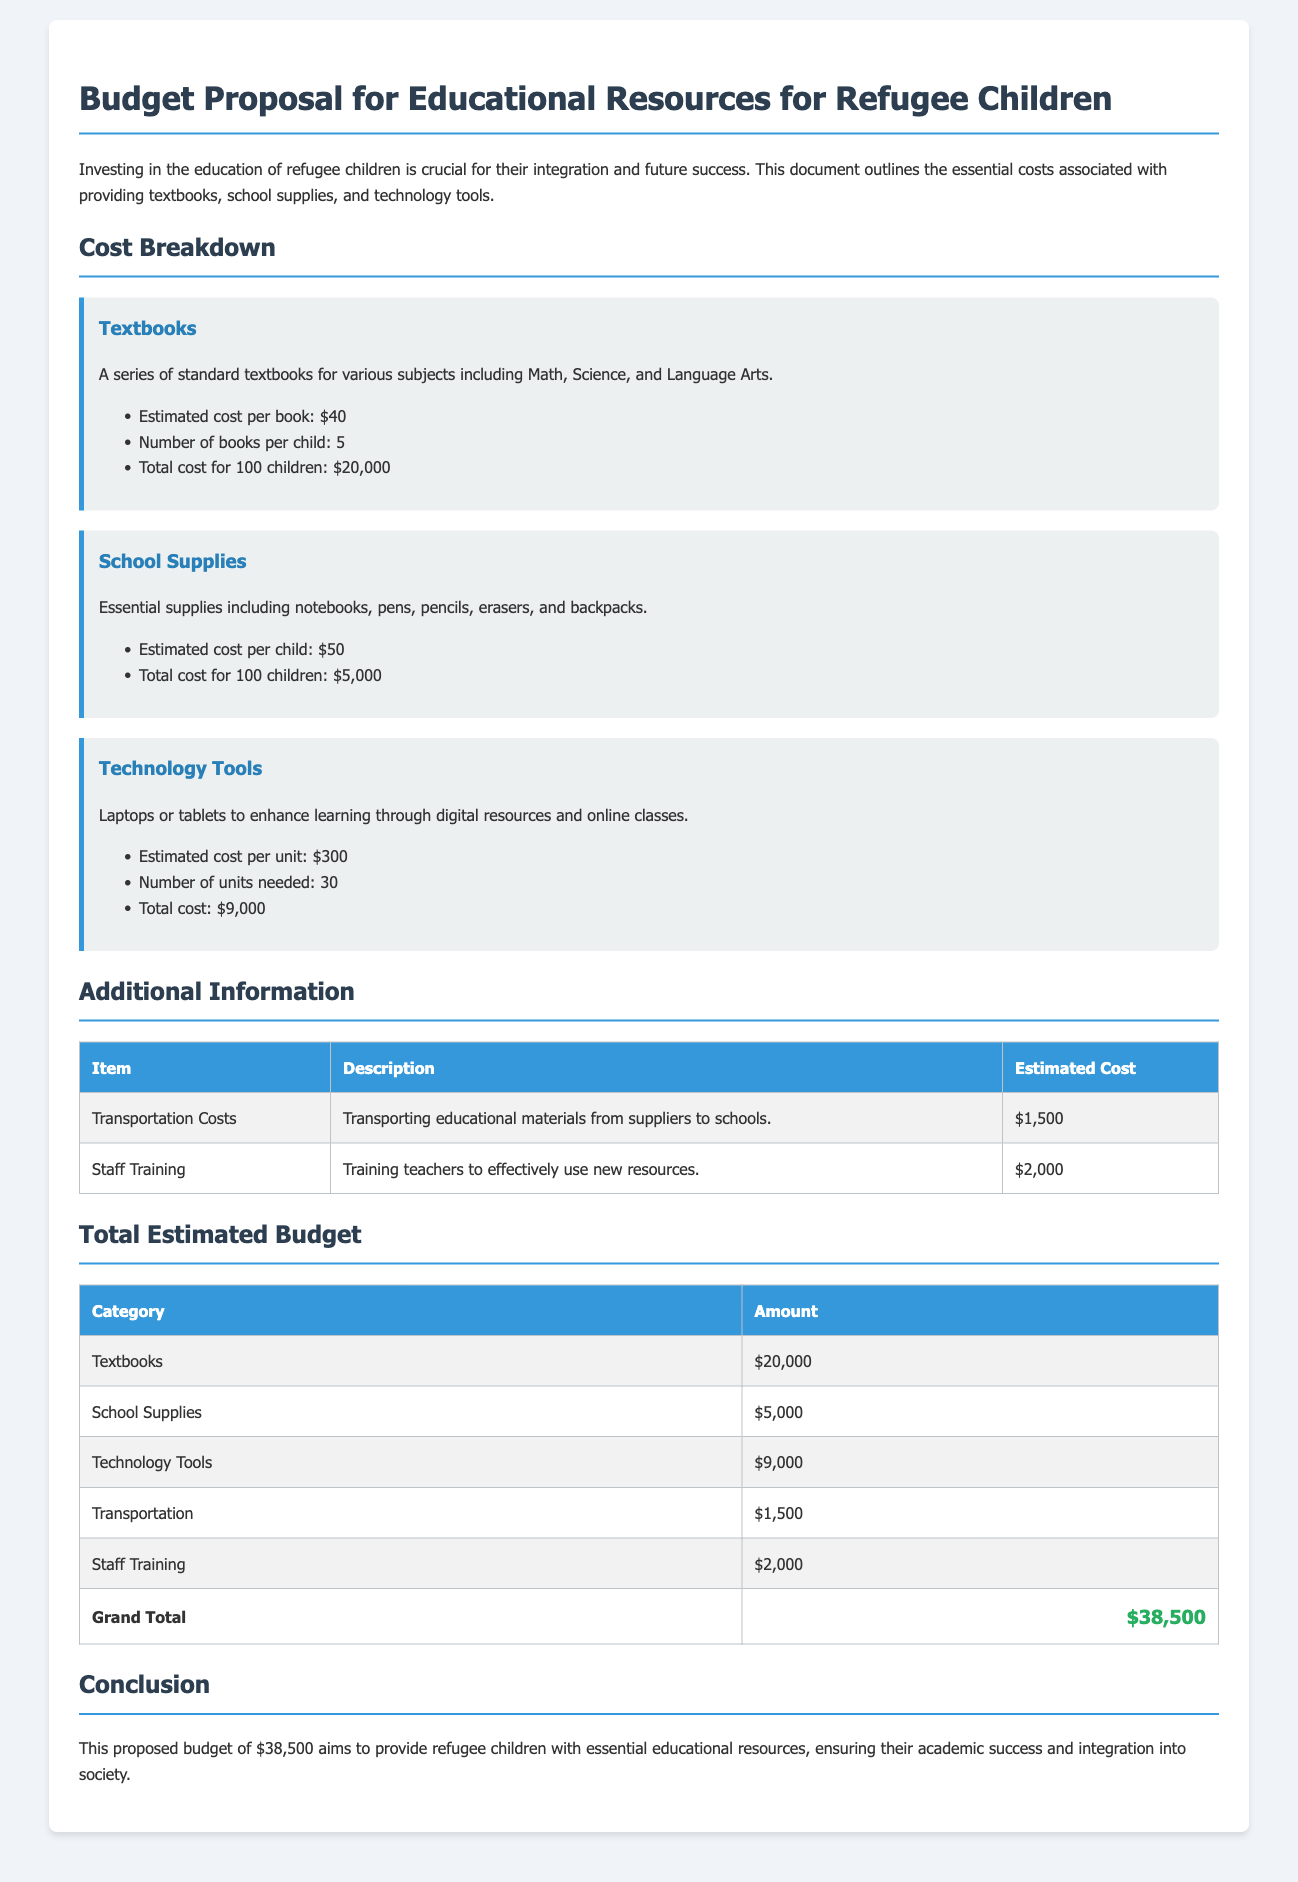What is the estimated cost per textbook? The document states that the estimated cost per book is $40.
Answer: $40 How many textbooks are provided per child? The document mentions that each child will receive 5 textbooks.
Answer: 5 What is the total cost for school supplies for 100 children? The total cost for school supplies for 100 children is listed as $5,000.
Answer: $5,000 What is the estimated cost per technology unit? The document specifies that the estimated cost per unit for technology tools is $300.
Answer: $300 What is the total estimated budget for providing resources? The grand total for the budget proposal is $38,500.
Answer: $38,500 What is the cost allocated for staff training? The document states that the estimated cost for staff training is $2,000.
Answer: $2,000 How many units of technology tools are needed? The document indicates that 30 units of technology tools are needed.
Answer: 30 What additional cost is included for transportation? The document outlines transportation costs totaling $1,500.
Answer: $1,500 What subjects do the textbooks cover? The document specifies that textbooks cover Math, Science, and Language Arts.
Answer: Math, Science, Language Arts 